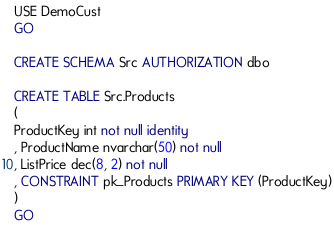<code> <loc_0><loc_0><loc_500><loc_500><_SQL_>USE DemoCust
GO

CREATE SCHEMA Src AUTHORIZATION dbo

CREATE TABLE Src.Products
(
ProductKey int not null identity
, ProductName nvarchar(50) not null
, ListPrice dec(8, 2) not null
, CONSTRAINT pk_Products PRIMARY KEY (ProductKey)
)
GO</code> 